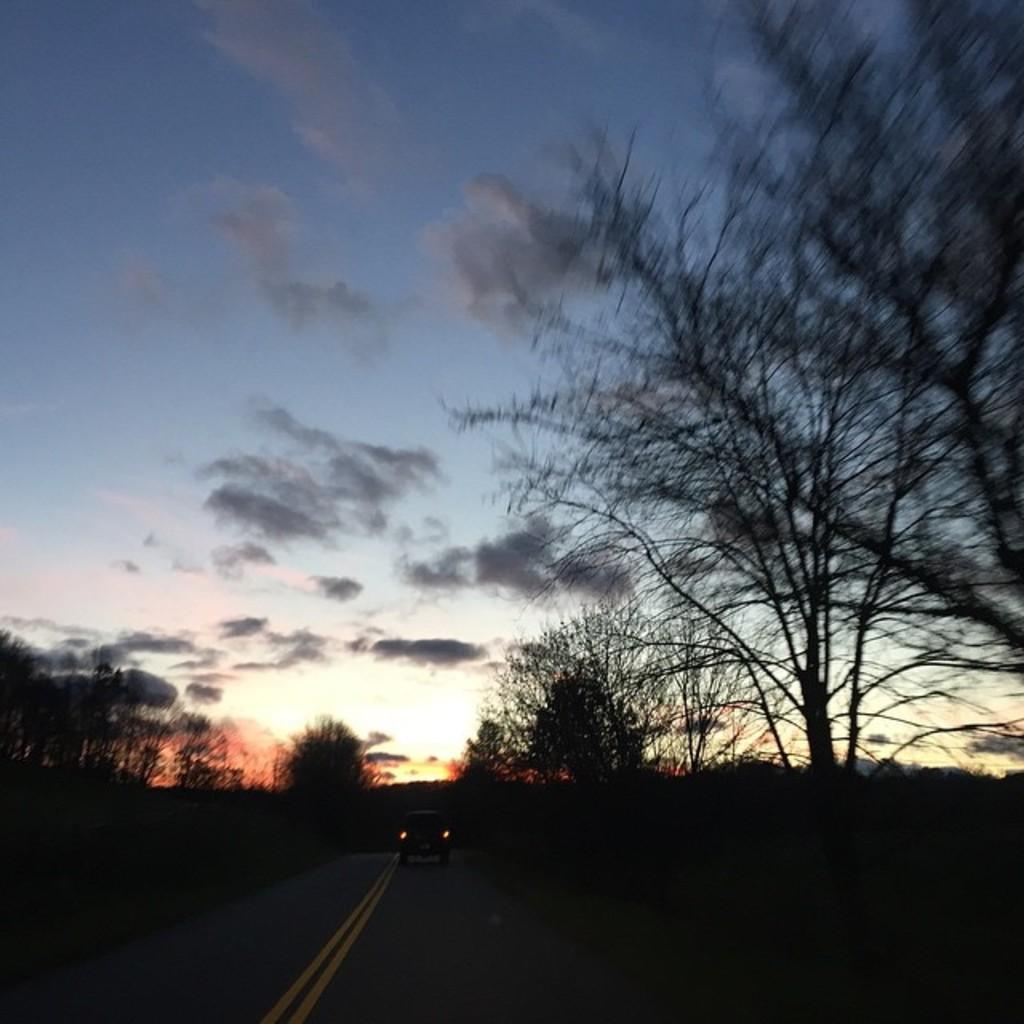What can be seen in the sky in the image? There are clouds in the image. What is on the road in the image? There is a vehicle on the road in the image. What type of vegetation is visible in the image? There are trees visible in the image. What type of silver material is present in the image? There is no silver material present in the image. What scientific discovery is depicted in the image? There is no scientific discovery depicted in the image; it features clouds, a vehicle, and trees. 